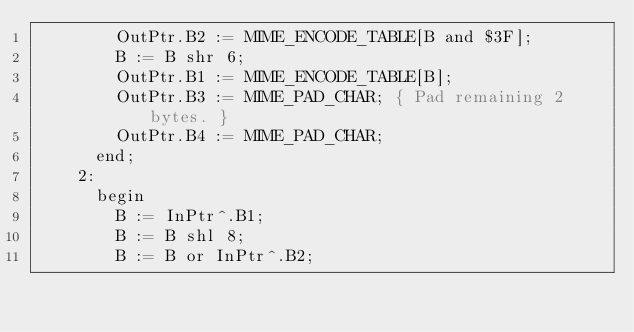<code> <loc_0><loc_0><loc_500><loc_500><_Pascal_>        OutPtr.B2 := MIME_ENCODE_TABLE[B and $3F];
        B := B shr 6;
        OutPtr.B1 := MIME_ENCODE_TABLE[B];
        OutPtr.B3 := MIME_PAD_CHAR; { Pad remaining 2 bytes. }
        OutPtr.B4 := MIME_PAD_CHAR;
      end;
    2:
      begin
        B := InPtr^.B1;
        B := B shl 8;
        B := B or InPtr^.B2;</code> 